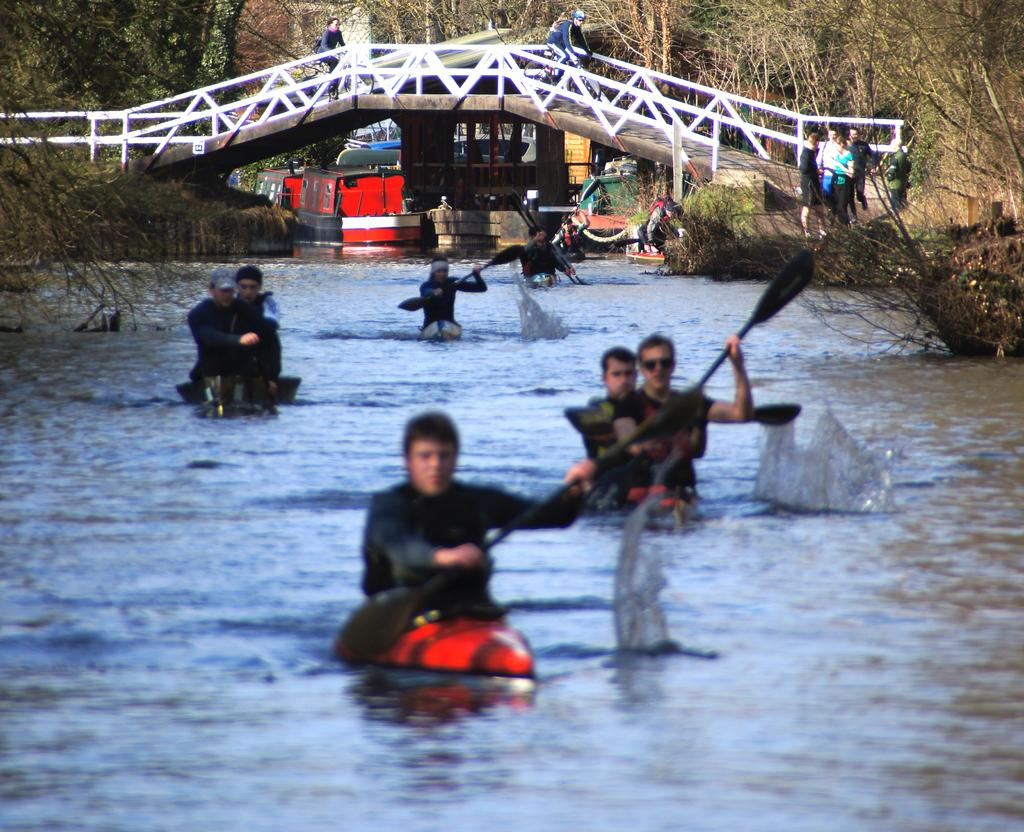What activity are the persons in the foreground of the image engaged in? The persons in the foreground of the image are rafting. Where is the rafting taking place? The rafting is taking place in a river. What can be seen in the background of the image? In the background of the image, there is a bridge, ships, persons riding bicycles, and trees. What type of book can be seen floating in the river in the image? There is no book visible in the image; the persons are rafting in a river. What type of sticks are being used by the persons riding bicycles in the image? There are no sticks mentioned or visible in the image; the persons are riding bicycles in the background. 